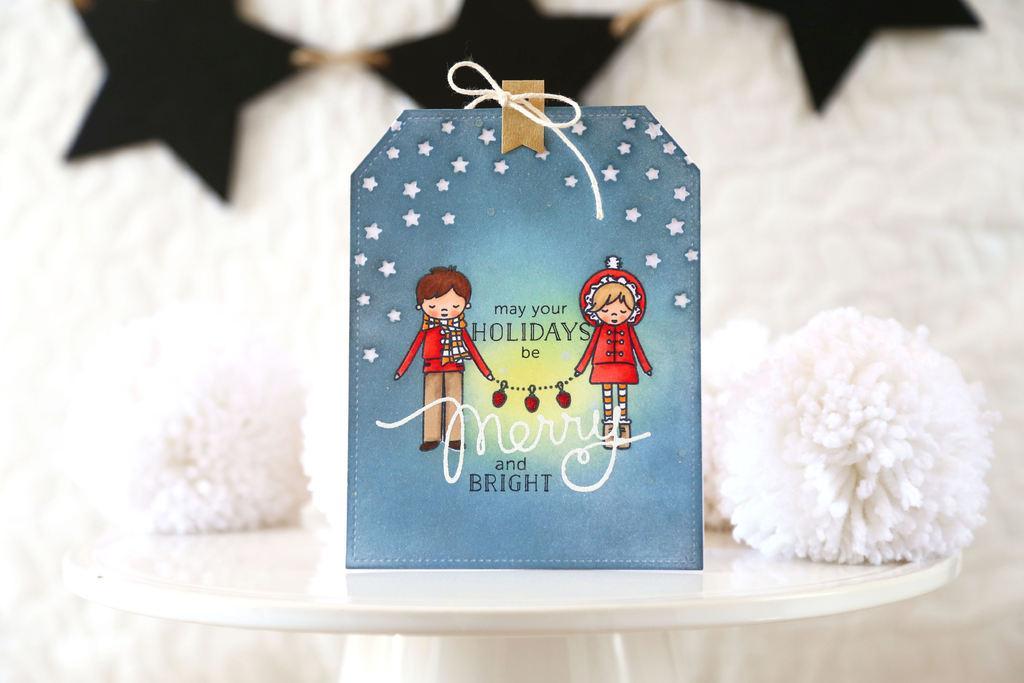Can you describe this image briefly? In this image I can see the card which is in blue color. I can see two people something is written on the card. In the background I can see the white and black color object. These are on the white color surface. 